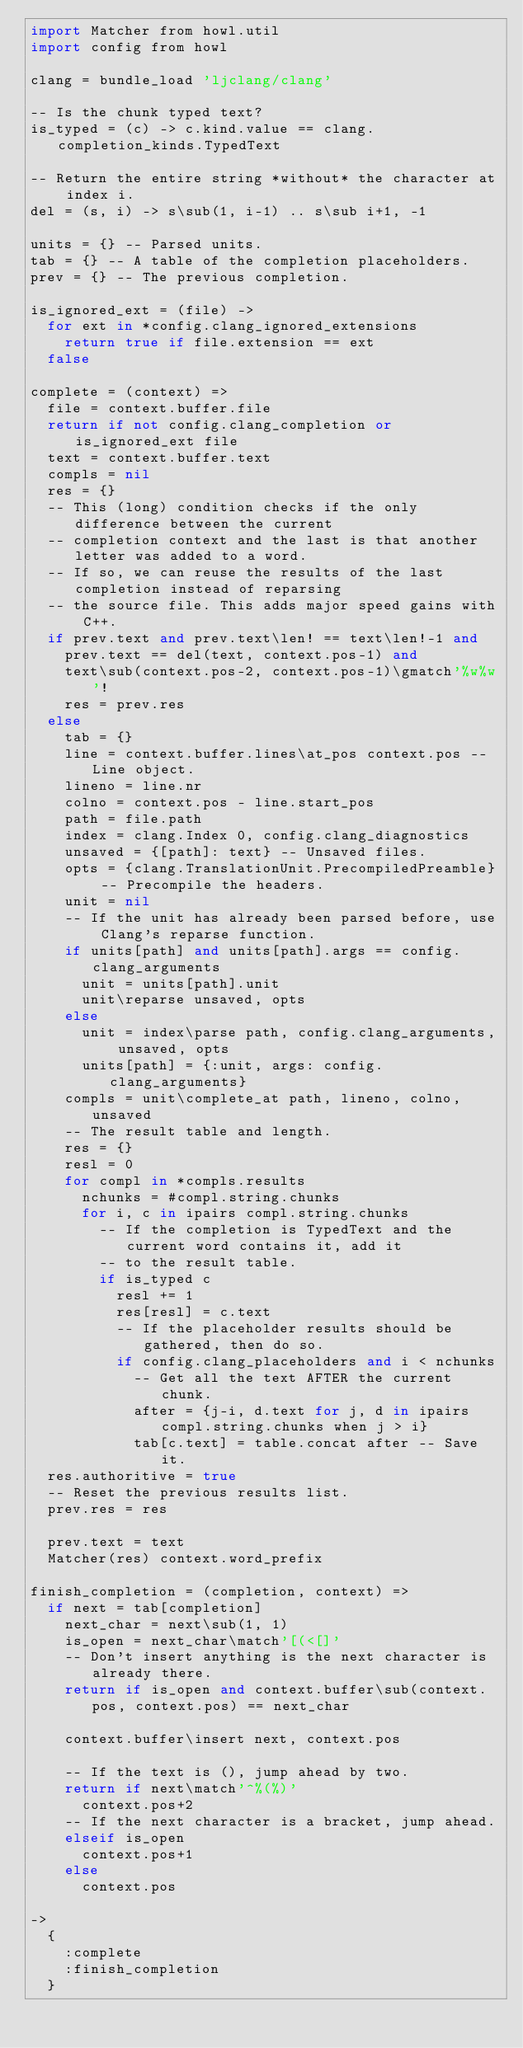Convert code to text. <code><loc_0><loc_0><loc_500><loc_500><_MoonScript_>import Matcher from howl.util
import config from howl

clang = bundle_load 'ljclang/clang'

-- Is the chunk typed text?
is_typed = (c) -> c.kind.value == clang.completion_kinds.TypedText

-- Return the entire string *without* the character at index i.
del = (s, i) -> s\sub(1, i-1) .. s\sub i+1, -1

units = {} -- Parsed units.
tab = {} -- A table of the completion placeholders.
prev = {} -- The previous completion.

is_ignored_ext = (file) ->
  for ext in *config.clang_ignored_extensions
    return true if file.extension == ext
  false

complete = (context) =>
  file = context.buffer.file
  return if not config.clang_completion or is_ignored_ext file
  text = context.buffer.text
  compls = nil
  res = {}
  -- This (long) condition checks if the only difference between the current
  -- completion context and the last is that another letter was added to a word.
  -- If so, we can reuse the results of the last completion instead of reparsing
  -- the source file. This adds major speed gains with C++.
  if prev.text and prev.text\len! == text\len!-1 and
    prev.text == del(text, context.pos-1) and
    text\sub(context.pos-2, context.pos-1)\gmatch'%w%w'!
    res = prev.res
  else
    tab = {}
    line = context.buffer.lines\at_pos context.pos -- Line object.
    lineno = line.nr
    colno = context.pos - line.start_pos
    path = file.path
    index = clang.Index 0, config.clang_diagnostics
    unsaved = {[path]: text} -- Unsaved files.
    opts = {clang.TranslationUnit.PrecompiledPreamble} -- Precompile the headers.
    unit = nil
    -- If the unit has already been parsed before, use Clang's reparse function.
    if units[path] and units[path].args == config.clang_arguments
      unit = units[path].unit
      unit\reparse unsaved, opts
    else
      unit = index\parse path, config.clang_arguments, unsaved, opts
      units[path] = {:unit, args: config.clang_arguments}
    compls = unit\complete_at path, lineno, colno, unsaved
    -- The result table and length.
    res = {}
    resl = 0
    for compl in *compls.results
      nchunks = #compl.string.chunks
      for i, c in ipairs compl.string.chunks
        -- If the completion is TypedText and the current word contains it, add it
        -- to the result table.
        if is_typed c
          resl += 1
          res[resl] = c.text
          -- If the placeholder results should be gathered, then do so.
          if config.clang_placeholders and i < nchunks
            -- Get all the text AFTER the current chunk.
            after = {j-i, d.text for j, d in ipairs compl.string.chunks when j > i}
            tab[c.text] = table.concat after -- Save it.
  res.authoritive = true
  -- Reset the previous results list.
  prev.res = res

  prev.text = text
  Matcher(res) context.word_prefix

finish_completion = (completion, context) =>
  if next = tab[completion]
    next_char = next\sub(1, 1)
    is_open = next_char\match'[(<[]'
    -- Don't insert anything is the next character is already there.
    return if is_open and context.buffer\sub(context.pos, context.pos) == next_char

    context.buffer\insert next, context.pos

    -- If the text is (), jump ahead by two.
    return if next\match'^%(%)'
      context.pos+2
    -- If the next character is a bracket, jump ahead.
    elseif is_open
      context.pos+1
    else
      context.pos

->
  {
    :complete
    :finish_completion
  }
</code> 